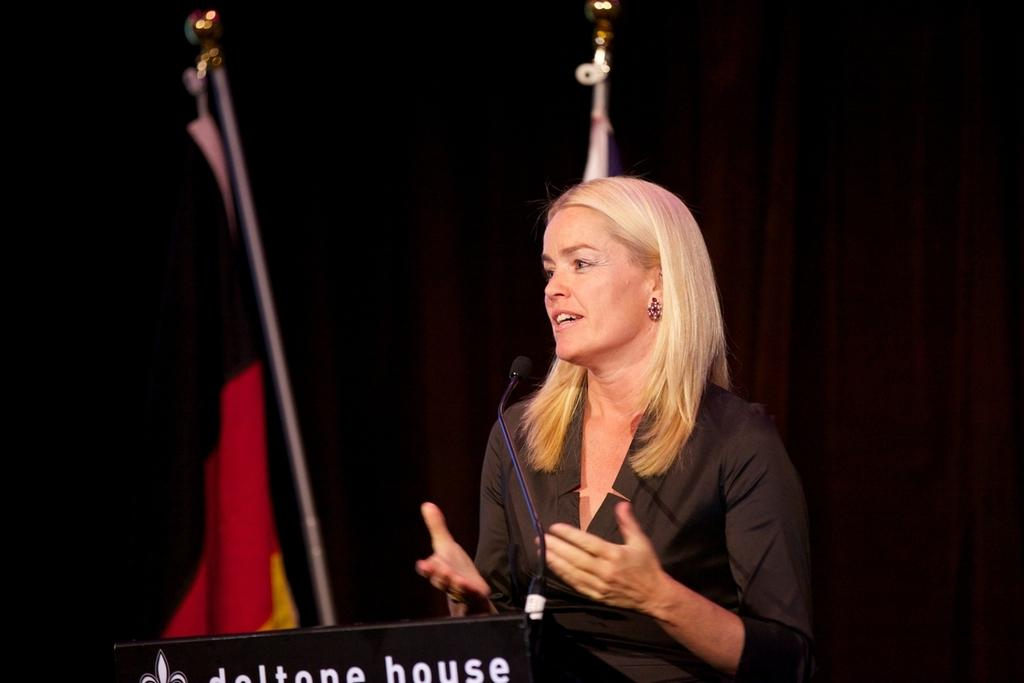Who is the main subject in the image? There is a lady in the center of the image. What object is in front of the lady? There is a microphone in front of the lady. What is the lady standing behind in the image? There is a desk in front of the lady. What can be seen in the background of the image? There is a black curtain in the background of the image. What type of skin condition is visible on the lady's face in the image? There is no indication of any skin condition visible on the lady's face in the image. 